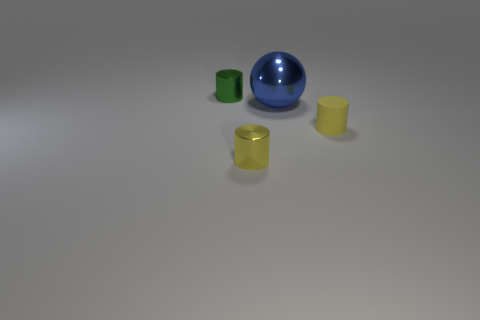The metallic object that is the same color as the tiny rubber object is what shape?
Make the answer very short. Cylinder. Does the rubber cylinder have the same color as the shiny thing that is in front of the big metal ball?
Offer a very short reply. Yes. The thing that is both behind the yellow metal object and in front of the blue sphere is made of what material?
Provide a succinct answer. Rubber. Is there anything else that has the same shape as the blue metal object?
Ensure brevity in your answer.  No. There is a big metallic object behind the small yellow thing that is right of the big blue shiny thing that is to the right of the tiny green metal object; what is its shape?
Offer a very short reply. Sphere. What shape is the tiny green thing that is made of the same material as the blue thing?
Offer a very short reply. Cylinder. What is the size of the blue ball?
Your response must be concise. Large. Is the green shiny cylinder the same size as the yellow shiny thing?
Provide a short and direct response. Yes. What number of things are yellow cylinders that are in front of the tiny matte cylinder or green metal cylinders behind the small yellow metal object?
Offer a terse response. 2. What number of small yellow shiny cylinders are behind the tiny metallic thing left of the metal cylinder in front of the small green metallic object?
Give a very brief answer. 0. 